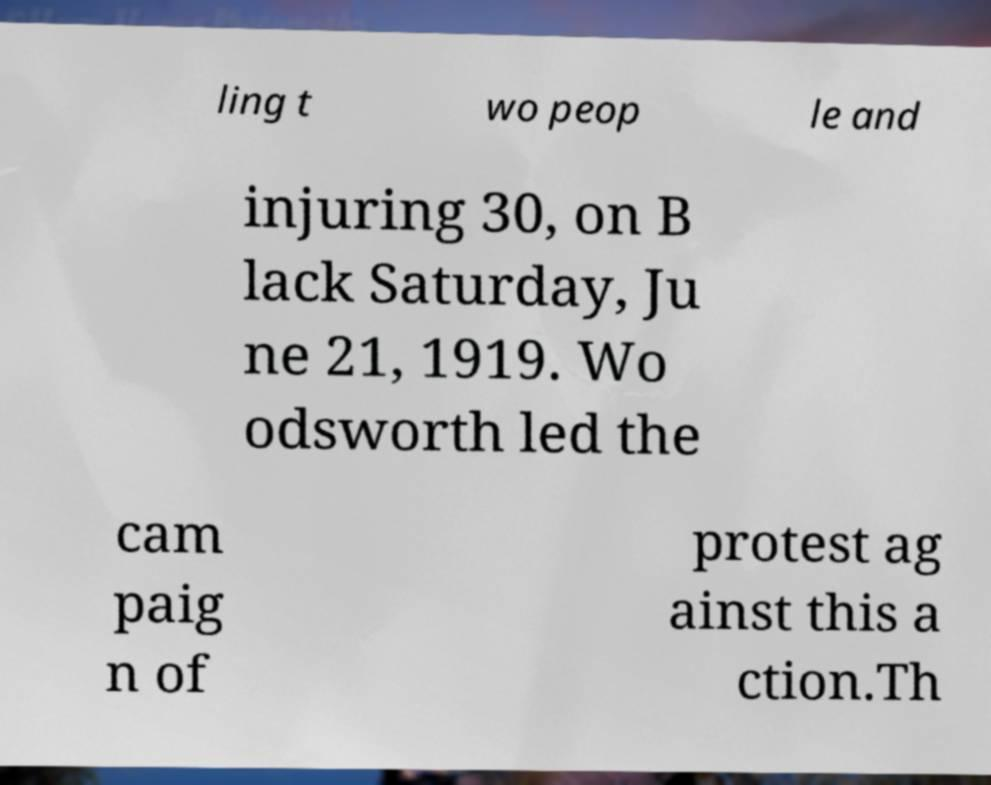There's text embedded in this image that I need extracted. Can you transcribe it verbatim? ling t wo peop le and injuring 30, on B lack Saturday, Ju ne 21, 1919. Wo odsworth led the cam paig n of protest ag ainst this a ction.Th 